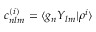Convert formula to latex. <formula><loc_0><loc_0><loc_500><loc_500>c _ { n l m } ^ { ( i ) } = \langle g _ { n } Y _ { l m } | \rho ^ { i } \rangle</formula> 